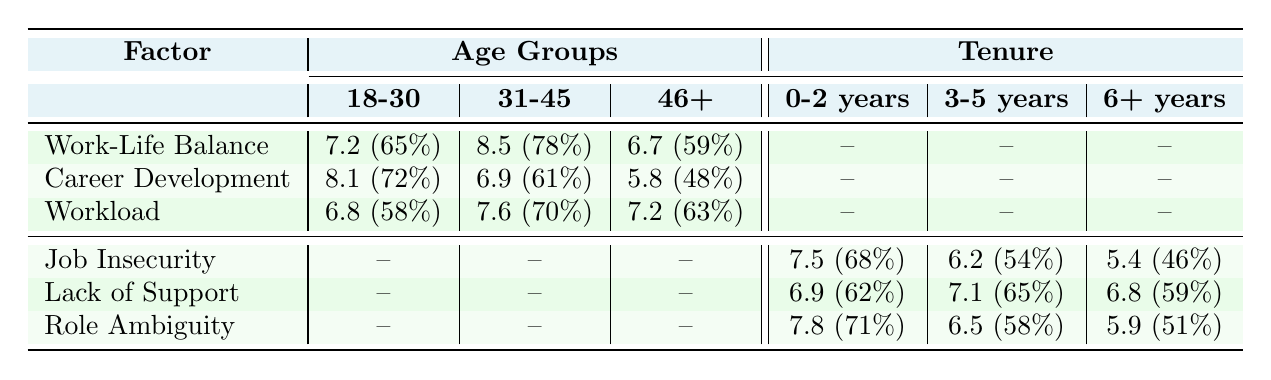What is the severity of Work-Life Balance for the age group 31-45? The severity score for Work-Life Balance in the age group 31-45 is listed directly in the table as 8.5.
Answer: 8.5 Which burnout factor has the highest severity in the age group 18-30? The table shows that Career Development has the highest severity score of 8.1 in the age group 18-30.
Answer: Career Development What is the prevalence percentage of Job Insecurity for employees with 0-2 years of tenure? The prevalence percentage for Job Insecurity in the 0-2 years tenure group is noted in the table as 68%.
Answer: 68% How does the severity of Workload in the age group 31-45 compare to the severity of Workload in the age group 46+? The severity for Workload in 31-45 is 7.6 and in 46+ it is 7.2. The difference is 7.6 - 7.2 = 0.4, indicating that it is higher by 0.4 in the 31-45 age group.
Answer: 0.4 Is the severity of Lack of Support lower in the 6+ years tenure group compared to the 0-2 years group? The severity of Lack of Support is 6.8 for 6+ years tenure and 6.9 for 0-2 years. Since 6.8 is less than 6.9, the statement is true.
Answer: Yes Which age group's severity for Career Development is higher than 6? The severities for Career Development are 8.1 (18-30) and 6.9 (31-45), both of which are higher than 6, while the 46+ group has a severity of 5.8, which is less than 6. Therefore, the age groups 18-30 and 31-45 meet the criteria.
Answer: 18-30 and 31-45 What is the average severity of Job Insecurity across all tenure groups? The severities for Job Insecurity in the tenure groups are 7.5, 6.2, and 5.4. The average is calculated as (7.5 + 6.2 + 5.4) / 3 = 6.3667, which rounds to approximately 6.37.
Answer: 6.37 How does the prevalence of Role Ambiguity in the 3-5 years tenure group compare to that in the 0-2 years group? The prevalence of Role Ambiguity is 58% for the 3-5 years group and 71% for the 0-2 years group. Since 58% < 71%, it indicates the prevalence is higher in the 0-2 years group.
Answer: Higher in 0-2 years group Are all burnout factors in the age group 46+ scored above 5? The table indicates severity scores of 6.7 (Work-Life Balance), 5.8 (Career Development), and 7.2 (Workload). Since all scores are above 5, the statement is true.
Answer: Yes Which age group has the lowest prevalence for the burnout factor Workload? The prevalences for Workload are 58% (18-30), 70% (31-45), and 63% (46+). The lowest prevalence is 58% in the age group 18-30.
Answer: 18-30 